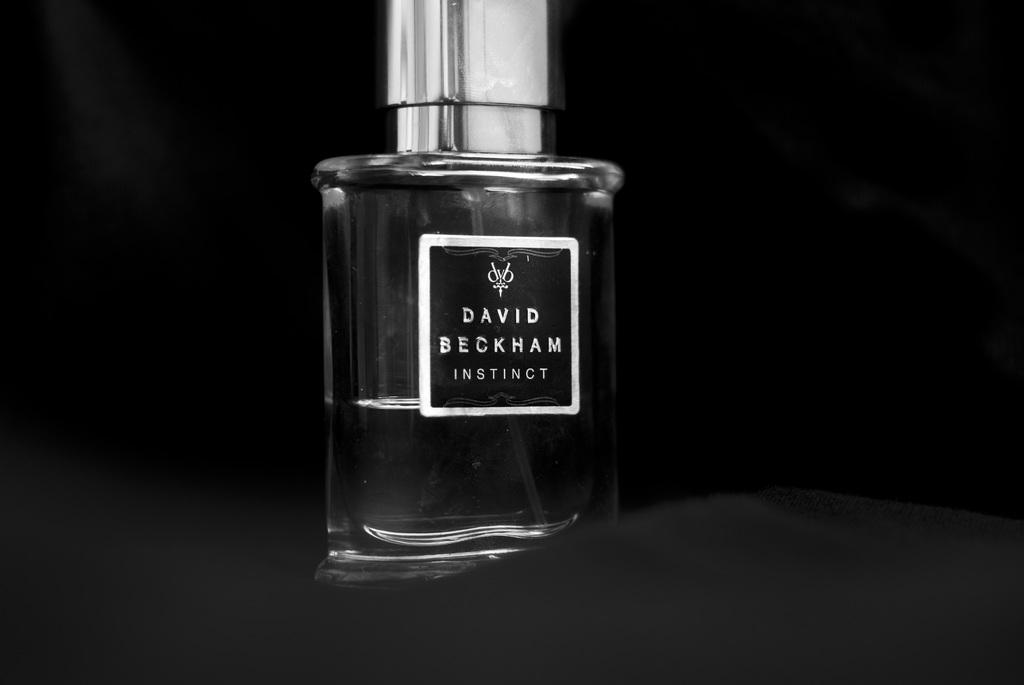<image>
Provide a brief description of the given image. A bottle of David Beckham Instinct Cologne against a black background. 